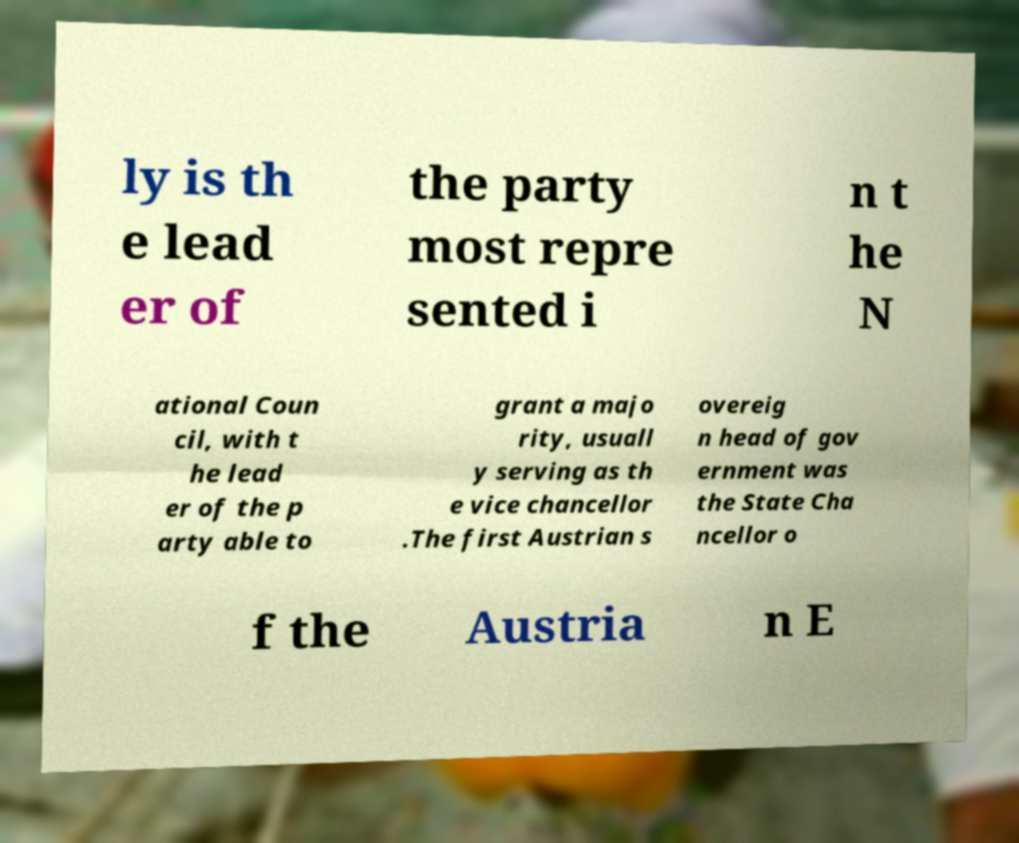Can you accurately transcribe the text from the provided image for me? ly is th e lead er of the party most repre sented i n t he N ational Coun cil, with t he lead er of the p arty able to grant a majo rity, usuall y serving as th e vice chancellor .The first Austrian s overeig n head of gov ernment was the State Cha ncellor o f the Austria n E 